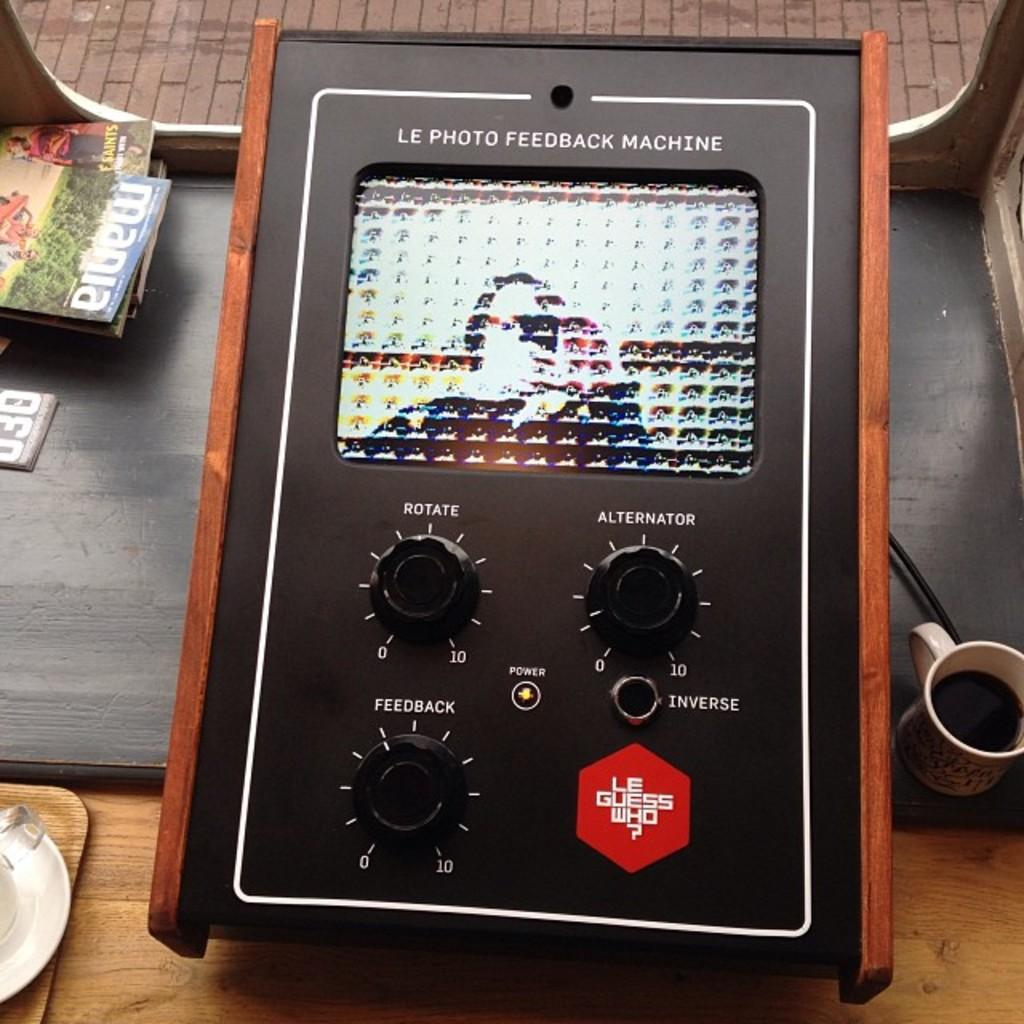<image>
Offer a succinct explanation of the picture presented. A Le Photo Feedback Machine has knobs for Rotate, Alternator, and Feedback. 